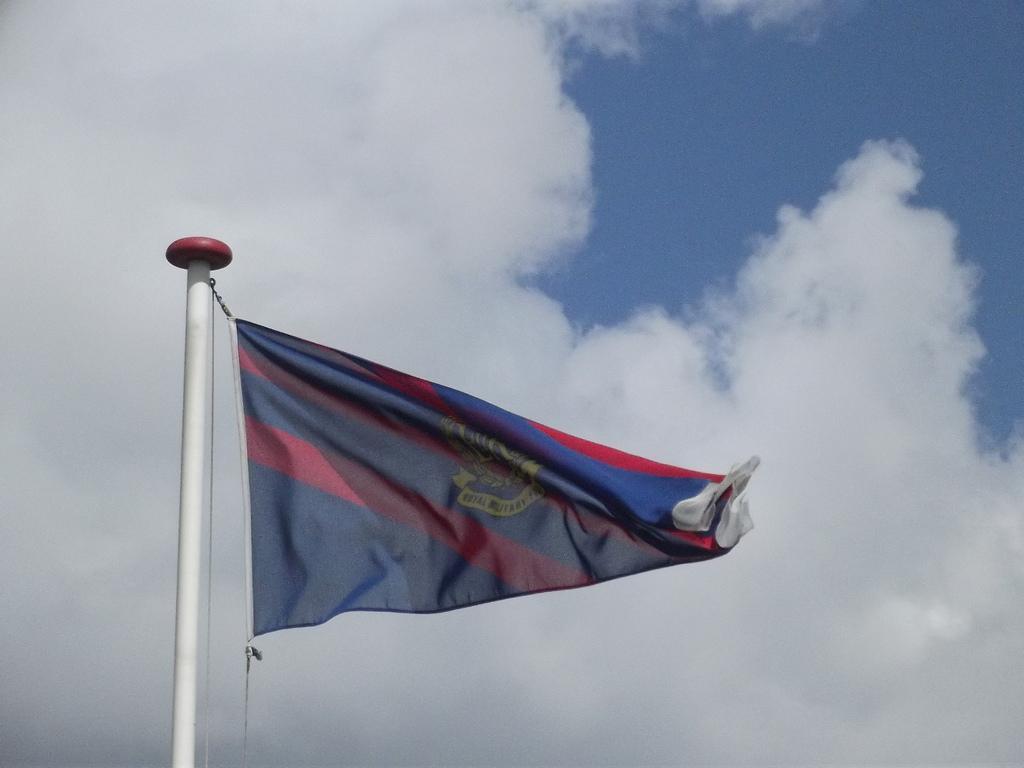Describe this image in one or two sentences. On the left side, there is a flag attached to a thread which is attached to a white color pole. In the background, there are clouds in the blue sky. 